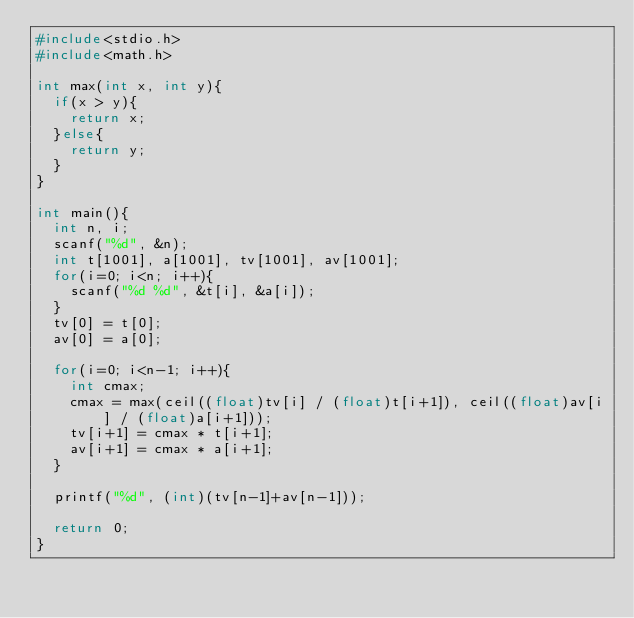Convert code to text. <code><loc_0><loc_0><loc_500><loc_500><_C_>#include<stdio.h>
#include<math.h>

int max(int x, int y){
  if(x > y){
    return x;
  }else{
    return y;
  }
}

int main(){
  int n, i;
  scanf("%d", &n);
  int t[1001], a[1001], tv[1001], av[1001];
  for(i=0; i<n; i++){
    scanf("%d %d", &t[i], &a[i]);
  }
  tv[0] = t[0];
  av[0] = a[0];

  for(i=0; i<n-1; i++){
    int cmax;
    cmax = max(ceil((float)tv[i] / (float)t[i+1]), ceil((float)av[i] / (float)a[i+1]));
    tv[i+1] = cmax * t[i+1];
    av[i+1] = cmax * a[i+1];
  }

  printf("%d", (int)(tv[n-1]+av[n-1]));

  return 0;
}
</code> 